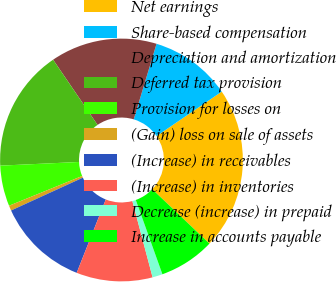Convert chart to OTSL. <chart><loc_0><loc_0><loc_500><loc_500><pie_chart><fcel>Net earnings<fcel>Share-based compensation<fcel>Depreciation and amortization<fcel>Deferred tax provision<fcel>Provision for losses on<fcel>(Gain) loss on sale of assets<fcel>(Increase) in receivables<fcel>(Increase) in inventories<fcel>Decrease (increase) in prepaid<fcel>Increase in accounts payable<nl><fcel>21.62%<fcel>10.81%<fcel>14.19%<fcel>16.22%<fcel>5.41%<fcel>0.68%<fcel>12.16%<fcel>10.14%<fcel>1.35%<fcel>7.43%<nl></chart> 